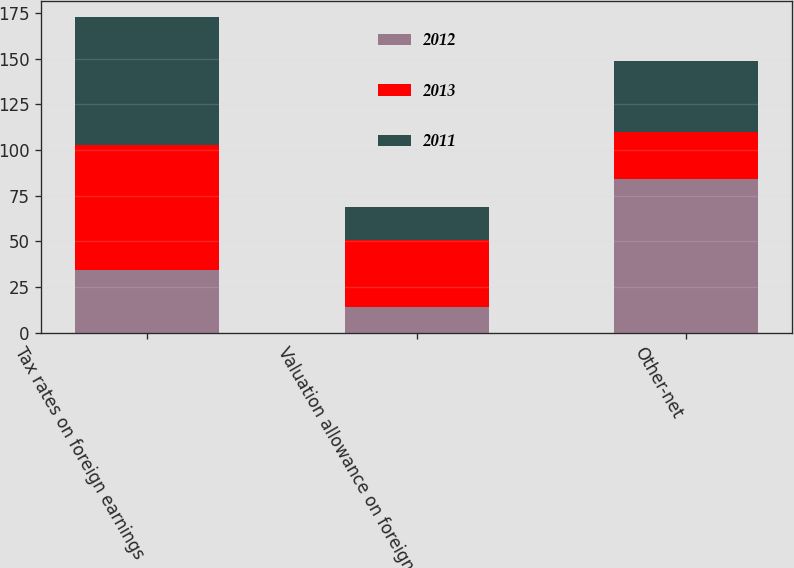<chart> <loc_0><loc_0><loc_500><loc_500><stacked_bar_chart><ecel><fcel>Tax rates on foreign earnings<fcel>Valuation allowance on foreign<fcel>Other-net<nl><fcel>2012<fcel>34<fcel>14<fcel>84<nl><fcel>2013<fcel>69<fcel>36.5<fcel>26<nl><fcel>2011<fcel>70<fcel>18<fcel>39<nl></chart> 